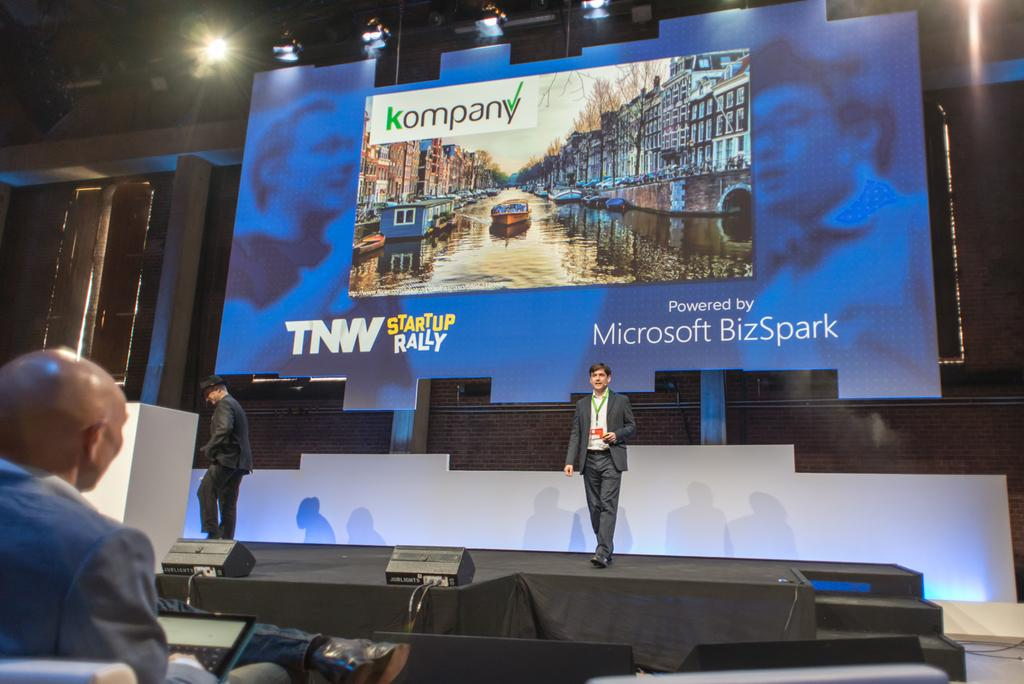<image>
Write a terse but informative summary of the picture. Big screen shows kompany TNW startup Rally powered by Microsoft Bizspark 